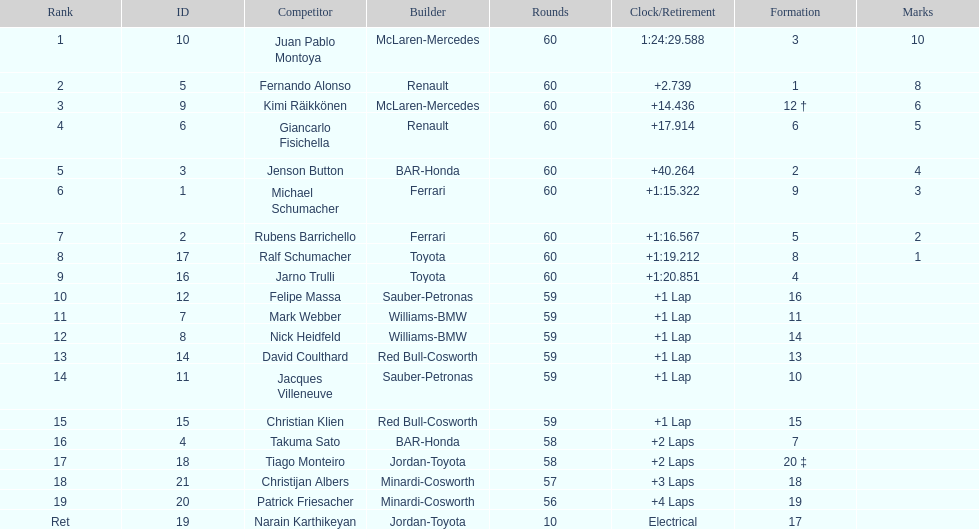Is there a points difference between the 9th position and 19th position on the list? No. 